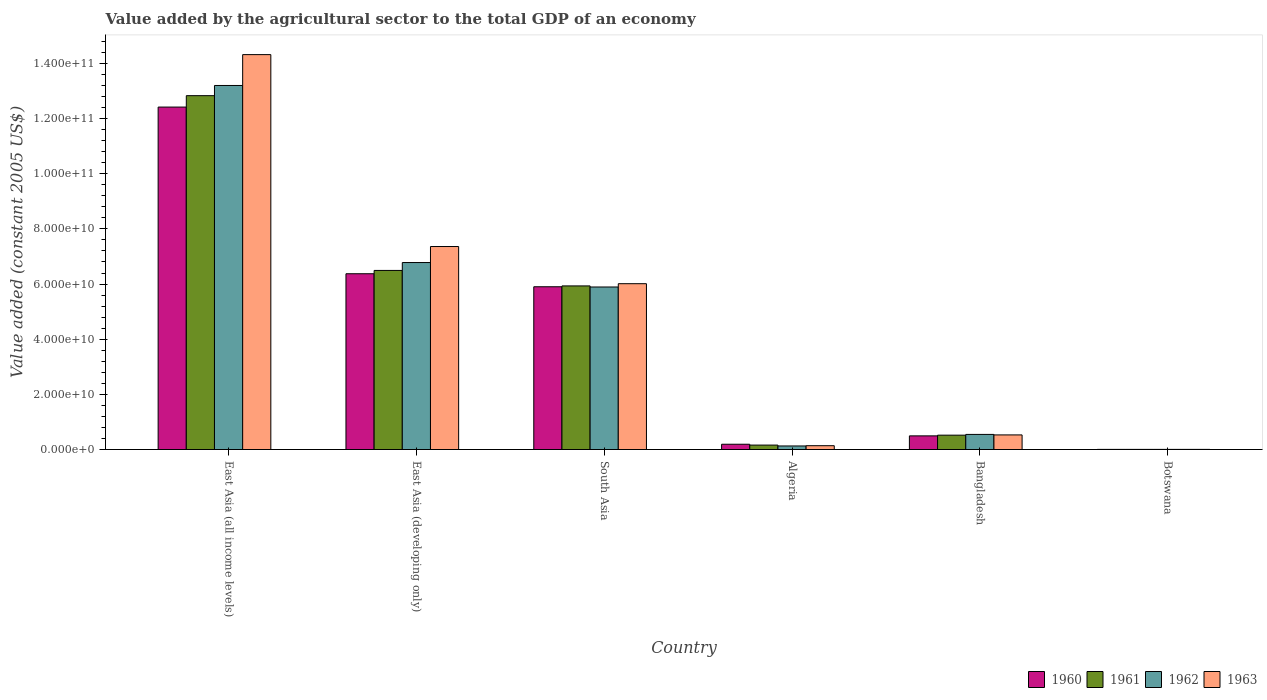Are the number of bars per tick equal to the number of legend labels?
Give a very brief answer. Yes. Are the number of bars on each tick of the X-axis equal?
Keep it short and to the point. Yes. How many bars are there on the 4th tick from the left?
Make the answer very short. 4. How many bars are there on the 3rd tick from the right?
Make the answer very short. 4. What is the label of the 3rd group of bars from the left?
Your answer should be compact. South Asia. What is the value added by the agricultural sector in 1960 in Bangladesh?
Offer a terse response. 4.95e+09. Across all countries, what is the maximum value added by the agricultural sector in 1961?
Provide a succinct answer. 1.28e+11. Across all countries, what is the minimum value added by the agricultural sector in 1960?
Provide a short and direct response. 4.74e+07. In which country was the value added by the agricultural sector in 1963 maximum?
Your answer should be compact. East Asia (all income levels). In which country was the value added by the agricultural sector in 1963 minimum?
Offer a very short reply. Botswana. What is the total value added by the agricultural sector in 1962 in the graph?
Provide a short and direct response. 2.66e+11. What is the difference between the value added by the agricultural sector in 1962 in East Asia (all income levels) and that in South Asia?
Give a very brief answer. 7.31e+1. What is the difference between the value added by the agricultural sector in 1960 in East Asia (all income levels) and the value added by the agricultural sector in 1961 in Algeria?
Your answer should be compact. 1.23e+11. What is the average value added by the agricultural sector in 1962 per country?
Provide a succinct answer. 4.43e+1. What is the difference between the value added by the agricultural sector of/in 1961 and value added by the agricultural sector of/in 1962 in Algeria?
Your answer should be compact. 3.18e+08. What is the ratio of the value added by the agricultural sector in 1963 in Botswana to that in South Asia?
Offer a terse response. 0. Is the difference between the value added by the agricultural sector in 1961 in Algeria and South Asia greater than the difference between the value added by the agricultural sector in 1962 in Algeria and South Asia?
Keep it short and to the point. No. What is the difference between the highest and the second highest value added by the agricultural sector in 1963?
Offer a terse response. -6.96e+1. What is the difference between the highest and the lowest value added by the agricultural sector in 1963?
Ensure brevity in your answer.  1.43e+11. In how many countries, is the value added by the agricultural sector in 1961 greater than the average value added by the agricultural sector in 1961 taken over all countries?
Give a very brief answer. 3. Is it the case that in every country, the sum of the value added by the agricultural sector in 1963 and value added by the agricultural sector in 1961 is greater than the sum of value added by the agricultural sector in 1962 and value added by the agricultural sector in 1960?
Give a very brief answer. No. What does the 4th bar from the right in South Asia represents?
Offer a terse response. 1960. Are all the bars in the graph horizontal?
Your answer should be very brief. No. Are the values on the major ticks of Y-axis written in scientific E-notation?
Ensure brevity in your answer.  Yes. What is the title of the graph?
Give a very brief answer. Value added by the agricultural sector to the total GDP of an economy. Does "1994" appear as one of the legend labels in the graph?
Give a very brief answer. No. What is the label or title of the X-axis?
Your answer should be very brief. Country. What is the label or title of the Y-axis?
Offer a terse response. Value added (constant 2005 US$). What is the Value added (constant 2005 US$) of 1960 in East Asia (all income levels)?
Give a very brief answer. 1.24e+11. What is the Value added (constant 2005 US$) of 1961 in East Asia (all income levels)?
Provide a succinct answer. 1.28e+11. What is the Value added (constant 2005 US$) of 1962 in East Asia (all income levels)?
Make the answer very short. 1.32e+11. What is the Value added (constant 2005 US$) of 1963 in East Asia (all income levels)?
Make the answer very short. 1.43e+11. What is the Value added (constant 2005 US$) in 1960 in East Asia (developing only)?
Give a very brief answer. 6.37e+1. What is the Value added (constant 2005 US$) in 1961 in East Asia (developing only)?
Offer a very short reply. 6.49e+1. What is the Value added (constant 2005 US$) in 1962 in East Asia (developing only)?
Make the answer very short. 6.78e+1. What is the Value added (constant 2005 US$) of 1963 in East Asia (developing only)?
Provide a short and direct response. 7.36e+1. What is the Value added (constant 2005 US$) of 1960 in South Asia?
Your answer should be compact. 5.90e+1. What is the Value added (constant 2005 US$) in 1961 in South Asia?
Provide a succinct answer. 5.93e+1. What is the Value added (constant 2005 US$) in 1962 in South Asia?
Make the answer very short. 5.89e+1. What is the Value added (constant 2005 US$) of 1963 in South Asia?
Make the answer very short. 6.01e+1. What is the Value added (constant 2005 US$) of 1960 in Algeria?
Offer a terse response. 1.92e+09. What is the Value added (constant 2005 US$) in 1961 in Algeria?
Offer a terse response. 1.61e+09. What is the Value added (constant 2005 US$) in 1962 in Algeria?
Offer a very short reply. 1.29e+09. What is the Value added (constant 2005 US$) of 1963 in Algeria?
Ensure brevity in your answer.  1.39e+09. What is the Value added (constant 2005 US$) of 1960 in Bangladesh?
Give a very brief answer. 4.95e+09. What is the Value added (constant 2005 US$) of 1961 in Bangladesh?
Offer a terse response. 5.21e+09. What is the Value added (constant 2005 US$) in 1962 in Bangladesh?
Give a very brief answer. 5.48e+09. What is the Value added (constant 2005 US$) in 1963 in Bangladesh?
Your response must be concise. 5.30e+09. What is the Value added (constant 2005 US$) in 1960 in Botswana?
Provide a short and direct response. 4.74e+07. What is the Value added (constant 2005 US$) in 1961 in Botswana?
Ensure brevity in your answer.  4.86e+07. What is the Value added (constant 2005 US$) of 1962 in Botswana?
Provide a succinct answer. 5.04e+07. What is the Value added (constant 2005 US$) in 1963 in Botswana?
Your answer should be very brief. 5.21e+07. Across all countries, what is the maximum Value added (constant 2005 US$) of 1960?
Your answer should be compact. 1.24e+11. Across all countries, what is the maximum Value added (constant 2005 US$) in 1961?
Your answer should be compact. 1.28e+11. Across all countries, what is the maximum Value added (constant 2005 US$) in 1962?
Offer a terse response. 1.32e+11. Across all countries, what is the maximum Value added (constant 2005 US$) in 1963?
Make the answer very short. 1.43e+11. Across all countries, what is the minimum Value added (constant 2005 US$) in 1960?
Provide a succinct answer. 4.74e+07. Across all countries, what is the minimum Value added (constant 2005 US$) of 1961?
Your answer should be compact. 4.86e+07. Across all countries, what is the minimum Value added (constant 2005 US$) in 1962?
Your answer should be compact. 5.04e+07. Across all countries, what is the minimum Value added (constant 2005 US$) in 1963?
Make the answer very short. 5.21e+07. What is the total Value added (constant 2005 US$) in 1960 in the graph?
Offer a terse response. 2.54e+11. What is the total Value added (constant 2005 US$) in 1961 in the graph?
Your response must be concise. 2.59e+11. What is the total Value added (constant 2005 US$) of 1962 in the graph?
Offer a very short reply. 2.66e+11. What is the total Value added (constant 2005 US$) in 1963 in the graph?
Provide a short and direct response. 2.84e+11. What is the difference between the Value added (constant 2005 US$) in 1960 in East Asia (all income levels) and that in East Asia (developing only)?
Provide a succinct answer. 6.04e+1. What is the difference between the Value added (constant 2005 US$) in 1961 in East Asia (all income levels) and that in East Asia (developing only)?
Keep it short and to the point. 6.34e+1. What is the difference between the Value added (constant 2005 US$) in 1962 in East Asia (all income levels) and that in East Asia (developing only)?
Ensure brevity in your answer.  6.42e+1. What is the difference between the Value added (constant 2005 US$) in 1963 in East Asia (all income levels) and that in East Asia (developing only)?
Provide a succinct answer. 6.96e+1. What is the difference between the Value added (constant 2005 US$) in 1960 in East Asia (all income levels) and that in South Asia?
Ensure brevity in your answer.  6.51e+1. What is the difference between the Value added (constant 2005 US$) in 1961 in East Asia (all income levels) and that in South Asia?
Give a very brief answer. 6.90e+1. What is the difference between the Value added (constant 2005 US$) in 1962 in East Asia (all income levels) and that in South Asia?
Offer a terse response. 7.31e+1. What is the difference between the Value added (constant 2005 US$) of 1963 in East Asia (all income levels) and that in South Asia?
Your response must be concise. 8.31e+1. What is the difference between the Value added (constant 2005 US$) in 1960 in East Asia (all income levels) and that in Algeria?
Keep it short and to the point. 1.22e+11. What is the difference between the Value added (constant 2005 US$) of 1961 in East Asia (all income levels) and that in Algeria?
Ensure brevity in your answer.  1.27e+11. What is the difference between the Value added (constant 2005 US$) of 1962 in East Asia (all income levels) and that in Algeria?
Keep it short and to the point. 1.31e+11. What is the difference between the Value added (constant 2005 US$) in 1963 in East Asia (all income levels) and that in Algeria?
Provide a short and direct response. 1.42e+11. What is the difference between the Value added (constant 2005 US$) in 1960 in East Asia (all income levels) and that in Bangladesh?
Offer a very short reply. 1.19e+11. What is the difference between the Value added (constant 2005 US$) of 1961 in East Asia (all income levels) and that in Bangladesh?
Provide a succinct answer. 1.23e+11. What is the difference between the Value added (constant 2005 US$) of 1962 in East Asia (all income levels) and that in Bangladesh?
Your answer should be compact. 1.27e+11. What is the difference between the Value added (constant 2005 US$) of 1963 in East Asia (all income levels) and that in Bangladesh?
Provide a succinct answer. 1.38e+11. What is the difference between the Value added (constant 2005 US$) of 1960 in East Asia (all income levels) and that in Botswana?
Give a very brief answer. 1.24e+11. What is the difference between the Value added (constant 2005 US$) of 1961 in East Asia (all income levels) and that in Botswana?
Keep it short and to the point. 1.28e+11. What is the difference between the Value added (constant 2005 US$) of 1962 in East Asia (all income levels) and that in Botswana?
Your response must be concise. 1.32e+11. What is the difference between the Value added (constant 2005 US$) of 1963 in East Asia (all income levels) and that in Botswana?
Provide a short and direct response. 1.43e+11. What is the difference between the Value added (constant 2005 US$) in 1960 in East Asia (developing only) and that in South Asia?
Make the answer very short. 4.72e+09. What is the difference between the Value added (constant 2005 US$) in 1961 in East Asia (developing only) and that in South Asia?
Offer a terse response. 5.62e+09. What is the difference between the Value added (constant 2005 US$) in 1962 in East Asia (developing only) and that in South Asia?
Offer a terse response. 8.86e+09. What is the difference between the Value added (constant 2005 US$) in 1963 in East Asia (developing only) and that in South Asia?
Your answer should be very brief. 1.35e+1. What is the difference between the Value added (constant 2005 US$) of 1960 in East Asia (developing only) and that in Algeria?
Offer a terse response. 6.18e+1. What is the difference between the Value added (constant 2005 US$) of 1961 in East Asia (developing only) and that in Algeria?
Offer a terse response. 6.33e+1. What is the difference between the Value added (constant 2005 US$) in 1962 in East Asia (developing only) and that in Algeria?
Offer a terse response. 6.65e+1. What is the difference between the Value added (constant 2005 US$) of 1963 in East Asia (developing only) and that in Algeria?
Your response must be concise. 7.22e+1. What is the difference between the Value added (constant 2005 US$) in 1960 in East Asia (developing only) and that in Bangladesh?
Keep it short and to the point. 5.88e+1. What is the difference between the Value added (constant 2005 US$) in 1961 in East Asia (developing only) and that in Bangladesh?
Provide a succinct answer. 5.97e+1. What is the difference between the Value added (constant 2005 US$) of 1962 in East Asia (developing only) and that in Bangladesh?
Your answer should be very brief. 6.23e+1. What is the difference between the Value added (constant 2005 US$) of 1963 in East Asia (developing only) and that in Bangladesh?
Your response must be concise. 6.83e+1. What is the difference between the Value added (constant 2005 US$) in 1960 in East Asia (developing only) and that in Botswana?
Make the answer very short. 6.37e+1. What is the difference between the Value added (constant 2005 US$) of 1961 in East Asia (developing only) and that in Botswana?
Give a very brief answer. 6.49e+1. What is the difference between the Value added (constant 2005 US$) in 1962 in East Asia (developing only) and that in Botswana?
Your response must be concise. 6.77e+1. What is the difference between the Value added (constant 2005 US$) of 1963 in East Asia (developing only) and that in Botswana?
Offer a terse response. 7.36e+1. What is the difference between the Value added (constant 2005 US$) in 1960 in South Asia and that in Algeria?
Ensure brevity in your answer.  5.71e+1. What is the difference between the Value added (constant 2005 US$) in 1961 in South Asia and that in Algeria?
Offer a very short reply. 5.77e+1. What is the difference between the Value added (constant 2005 US$) of 1962 in South Asia and that in Algeria?
Your answer should be compact. 5.76e+1. What is the difference between the Value added (constant 2005 US$) of 1963 in South Asia and that in Algeria?
Make the answer very short. 5.87e+1. What is the difference between the Value added (constant 2005 US$) of 1960 in South Asia and that in Bangladesh?
Offer a very short reply. 5.41e+1. What is the difference between the Value added (constant 2005 US$) of 1961 in South Asia and that in Bangladesh?
Your response must be concise. 5.41e+1. What is the difference between the Value added (constant 2005 US$) in 1962 in South Asia and that in Bangladesh?
Provide a short and direct response. 5.35e+1. What is the difference between the Value added (constant 2005 US$) of 1963 in South Asia and that in Bangladesh?
Your answer should be very brief. 5.48e+1. What is the difference between the Value added (constant 2005 US$) of 1960 in South Asia and that in Botswana?
Keep it short and to the point. 5.90e+1. What is the difference between the Value added (constant 2005 US$) of 1961 in South Asia and that in Botswana?
Your answer should be compact. 5.93e+1. What is the difference between the Value added (constant 2005 US$) of 1962 in South Asia and that in Botswana?
Your answer should be compact. 5.89e+1. What is the difference between the Value added (constant 2005 US$) of 1963 in South Asia and that in Botswana?
Your answer should be compact. 6.01e+1. What is the difference between the Value added (constant 2005 US$) in 1960 in Algeria and that in Bangladesh?
Your response must be concise. -3.03e+09. What is the difference between the Value added (constant 2005 US$) in 1961 in Algeria and that in Bangladesh?
Offer a terse response. -3.60e+09. What is the difference between the Value added (constant 2005 US$) in 1962 in Algeria and that in Bangladesh?
Offer a very short reply. -4.19e+09. What is the difference between the Value added (constant 2005 US$) of 1963 in Algeria and that in Bangladesh?
Offer a terse response. -3.91e+09. What is the difference between the Value added (constant 2005 US$) in 1960 in Algeria and that in Botswana?
Provide a short and direct response. 1.87e+09. What is the difference between the Value added (constant 2005 US$) of 1961 in Algeria and that in Botswana?
Your response must be concise. 1.56e+09. What is the difference between the Value added (constant 2005 US$) in 1962 in Algeria and that in Botswana?
Offer a terse response. 1.24e+09. What is the difference between the Value added (constant 2005 US$) of 1963 in Algeria and that in Botswana?
Make the answer very short. 1.34e+09. What is the difference between the Value added (constant 2005 US$) of 1960 in Bangladesh and that in Botswana?
Your answer should be compact. 4.90e+09. What is the difference between the Value added (constant 2005 US$) of 1961 in Bangladesh and that in Botswana?
Ensure brevity in your answer.  5.16e+09. What is the difference between the Value added (constant 2005 US$) in 1962 in Bangladesh and that in Botswana?
Keep it short and to the point. 5.43e+09. What is the difference between the Value added (constant 2005 US$) of 1963 in Bangladesh and that in Botswana?
Your answer should be very brief. 5.24e+09. What is the difference between the Value added (constant 2005 US$) of 1960 in East Asia (all income levels) and the Value added (constant 2005 US$) of 1961 in East Asia (developing only)?
Provide a succinct answer. 5.92e+1. What is the difference between the Value added (constant 2005 US$) of 1960 in East Asia (all income levels) and the Value added (constant 2005 US$) of 1962 in East Asia (developing only)?
Your answer should be very brief. 5.64e+1. What is the difference between the Value added (constant 2005 US$) in 1960 in East Asia (all income levels) and the Value added (constant 2005 US$) in 1963 in East Asia (developing only)?
Your response must be concise. 5.06e+1. What is the difference between the Value added (constant 2005 US$) of 1961 in East Asia (all income levels) and the Value added (constant 2005 US$) of 1962 in East Asia (developing only)?
Give a very brief answer. 6.05e+1. What is the difference between the Value added (constant 2005 US$) of 1961 in East Asia (all income levels) and the Value added (constant 2005 US$) of 1963 in East Asia (developing only)?
Offer a very short reply. 5.47e+1. What is the difference between the Value added (constant 2005 US$) in 1962 in East Asia (all income levels) and the Value added (constant 2005 US$) in 1963 in East Asia (developing only)?
Keep it short and to the point. 5.84e+1. What is the difference between the Value added (constant 2005 US$) of 1960 in East Asia (all income levels) and the Value added (constant 2005 US$) of 1961 in South Asia?
Provide a short and direct response. 6.48e+1. What is the difference between the Value added (constant 2005 US$) in 1960 in East Asia (all income levels) and the Value added (constant 2005 US$) in 1962 in South Asia?
Offer a terse response. 6.52e+1. What is the difference between the Value added (constant 2005 US$) of 1960 in East Asia (all income levels) and the Value added (constant 2005 US$) of 1963 in South Asia?
Make the answer very short. 6.40e+1. What is the difference between the Value added (constant 2005 US$) in 1961 in East Asia (all income levels) and the Value added (constant 2005 US$) in 1962 in South Asia?
Give a very brief answer. 6.94e+1. What is the difference between the Value added (constant 2005 US$) in 1961 in East Asia (all income levels) and the Value added (constant 2005 US$) in 1963 in South Asia?
Your answer should be very brief. 6.82e+1. What is the difference between the Value added (constant 2005 US$) in 1962 in East Asia (all income levels) and the Value added (constant 2005 US$) in 1963 in South Asia?
Keep it short and to the point. 7.19e+1. What is the difference between the Value added (constant 2005 US$) of 1960 in East Asia (all income levels) and the Value added (constant 2005 US$) of 1961 in Algeria?
Offer a terse response. 1.23e+11. What is the difference between the Value added (constant 2005 US$) of 1960 in East Asia (all income levels) and the Value added (constant 2005 US$) of 1962 in Algeria?
Keep it short and to the point. 1.23e+11. What is the difference between the Value added (constant 2005 US$) of 1960 in East Asia (all income levels) and the Value added (constant 2005 US$) of 1963 in Algeria?
Your answer should be compact. 1.23e+11. What is the difference between the Value added (constant 2005 US$) in 1961 in East Asia (all income levels) and the Value added (constant 2005 US$) in 1962 in Algeria?
Offer a terse response. 1.27e+11. What is the difference between the Value added (constant 2005 US$) in 1961 in East Asia (all income levels) and the Value added (constant 2005 US$) in 1963 in Algeria?
Your response must be concise. 1.27e+11. What is the difference between the Value added (constant 2005 US$) in 1962 in East Asia (all income levels) and the Value added (constant 2005 US$) in 1963 in Algeria?
Provide a succinct answer. 1.31e+11. What is the difference between the Value added (constant 2005 US$) of 1960 in East Asia (all income levels) and the Value added (constant 2005 US$) of 1961 in Bangladesh?
Your response must be concise. 1.19e+11. What is the difference between the Value added (constant 2005 US$) of 1960 in East Asia (all income levels) and the Value added (constant 2005 US$) of 1962 in Bangladesh?
Your answer should be compact. 1.19e+11. What is the difference between the Value added (constant 2005 US$) in 1960 in East Asia (all income levels) and the Value added (constant 2005 US$) in 1963 in Bangladesh?
Provide a short and direct response. 1.19e+11. What is the difference between the Value added (constant 2005 US$) of 1961 in East Asia (all income levels) and the Value added (constant 2005 US$) of 1962 in Bangladesh?
Give a very brief answer. 1.23e+11. What is the difference between the Value added (constant 2005 US$) in 1961 in East Asia (all income levels) and the Value added (constant 2005 US$) in 1963 in Bangladesh?
Your answer should be compact. 1.23e+11. What is the difference between the Value added (constant 2005 US$) of 1962 in East Asia (all income levels) and the Value added (constant 2005 US$) of 1963 in Bangladesh?
Keep it short and to the point. 1.27e+11. What is the difference between the Value added (constant 2005 US$) of 1960 in East Asia (all income levels) and the Value added (constant 2005 US$) of 1961 in Botswana?
Your answer should be compact. 1.24e+11. What is the difference between the Value added (constant 2005 US$) in 1960 in East Asia (all income levels) and the Value added (constant 2005 US$) in 1962 in Botswana?
Provide a short and direct response. 1.24e+11. What is the difference between the Value added (constant 2005 US$) in 1960 in East Asia (all income levels) and the Value added (constant 2005 US$) in 1963 in Botswana?
Offer a very short reply. 1.24e+11. What is the difference between the Value added (constant 2005 US$) in 1961 in East Asia (all income levels) and the Value added (constant 2005 US$) in 1962 in Botswana?
Provide a succinct answer. 1.28e+11. What is the difference between the Value added (constant 2005 US$) of 1961 in East Asia (all income levels) and the Value added (constant 2005 US$) of 1963 in Botswana?
Give a very brief answer. 1.28e+11. What is the difference between the Value added (constant 2005 US$) of 1962 in East Asia (all income levels) and the Value added (constant 2005 US$) of 1963 in Botswana?
Offer a very short reply. 1.32e+11. What is the difference between the Value added (constant 2005 US$) of 1960 in East Asia (developing only) and the Value added (constant 2005 US$) of 1961 in South Asia?
Provide a succinct answer. 4.42e+09. What is the difference between the Value added (constant 2005 US$) of 1960 in East Asia (developing only) and the Value added (constant 2005 US$) of 1962 in South Asia?
Your answer should be compact. 4.81e+09. What is the difference between the Value added (constant 2005 US$) of 1960 in East Asia (developing only) and the Value added (constant 2005 US$) of 1963 in South Asia?
Keep it short and to the point. 3.61e+09. What is the difference between the Value added (constant 2005 US$) in 1961 in East Asia (developing only) and the Value added (constant 2005 US$) in 1962 in South Asia?
Give a very brief answer. 6.00e+09. What is the difference between the Value added (constant 2005 US$) of 1961 in East Asia (developing only) and the Value added (constant 2005 US$) of 1963 in South Asia?
Keep it short and to the point. 4.81e+09. What is the difference between the Value added (constant 2005 US$) in 1962 in East Asia (developing only) and the Value added (constant 2005 US$) in 1963 in South Asia?
Your answer should be very brief. 7.67e+09. What is the difference between the Value added (constant 2005 US$) in 1960 in East Asia (developing only) and the Value added (constant 2005 US$) in 1961 in Algeria?
Keep it short and to the point. 6.21e+1. What is the difference between the Value added (constant 2005 US$) in 1960 in East Asia (developing only) and the Value added (constant 2005 US$) in 1962 in Algeria?
Offer a terse response. 6.24e+1. What is the difference between the Value added (constant 2005 US$) in 1960 in East Asia (developing only) and the Value added (constant 2005 US$) in 1963 in Algeria?
Your response must be concise. 6.23e+1. What is the difference between the Value added (constant 2005 US$) of 1961 in East Asia (developing only) and the Value added (constant 2005 US$) of 1962 in Algeria?
Your answer should be compact. 6.36e+1. What is the difference between the Value added (constant 2005 US$) in 1961 in East Asia (developing only) and the Value added (constant 2005 US$) in 1963 in Algeria?
Make the answer very short. 6.35e+1. What is the difference between the Value added (constant 2005 US$) of 1962 in East Asia (developing only) and the Value added (constant 2005 US$) of 1963 in Algeria?
Your answer should be very brief. 6.64e+1. What is the difference between the Value added (constant 2005 US$) in 1960 in East Asia (developing only) and the Value added (constant 2005 US$) in 1961 in Bangladesh?
Your answer should be very brief. 5.85e+1. What is the difference between the Value added (constant 2005 US$) in 1960 in East Asia (developing only) and the Value added (constant 2005 US$) in 1962 in Bangladesh?
Offer a very short reply. 5.83e+1. What is the difference between the Value added (constant 2005 US$) of 1960 in East Asia (developing only) and the Value added (constant 2005 US$) of 1963 in Bangladesh?
Provide a short and direct response. 5.84e+1. What is the difference between the Value added (constant 2005 US$) of 1961 in East Asia (developing only) and the Value added (constant 2005 US$) of 1962 in Bangladesh?
Make the answer very short. 5.95e+1. What is the difference between the Value added (constant 2005 US$) in 1961 in East Asia (developing only) and the Value added (constant 2005 US$) in 1963 in Bangladesh?
Make the answer very short. 5.96e+1. What is the difference between the Value added (constant 2005 US$) of 1962 in East Asia (developing only) and the Value added (constant 2005 US$) of 1963 in Bangladesh?
Your answer should be compact. 6.25e+1. What is the difference between the Value added (constant 2005 US$) of 1960 in East Asia (developing only) and the Value added (constant 2005 US$) of 1961 in Botswana?
Offer a terse response. 6.37e+1. What is the difference between the Value added (constant 2005 US$) in 1960 in East Asia (developing only) and the Value added (constant 2005 US$) in 1962 in Botswana?
Provide a succinct answer. 6.37e+1. What is the difference between the Value added (constant 2005 US$) in 1960 in East Asia (developing only) and the Value added (constant 2005 US$) in 1963 in Botswana?
Keep it short and to the point. 6.37e+1. What is the difference between the Value added (constant 2005 US$) in 1961 in East Asia (developing only) and the Value added (constant 2005 US$) in 1962 in Botswana?
Offer a terse response. 6.49e+1. What is the difference between the Value added (constant 2005 US$) in 1961 in East Asia (developing only) and the Value added (constant 2005 US$) in 1963 in Botswana?
Give a very brief answer. 6.49e+1. What is the difference between the Value added (constant 2005 US$) in 1962 in East Asia (developing only) and the Value added (constant 2005 US$) in 1963 in Botswana?
Make the answer very short. 6.77e+1. What is the difference between the Value added (constant 2005 US$) in 1960 in South Asia and the Value added (constant 2005 US$) in 1961 in Algeria?
Keep it short and to the point. 5.74e+1. What is the difference between the Value added (constant 2005 US$) in 1960 in South Asia and the Value added (constant 2005 US$) in 1962 in Algeria?
Provide a succinct answer. 5.77e+1. What is the difference between the Value added (constant 2005 US$) in 1960 in South Asia and the Value added (constant 2005 US$) in 1963 in Algeria?
Your answer should be compact. 5.76e+1. What is the difference between the Value added (constant 2005 US$) of 1961 in South Asia and the Value added (constant 2005 US$) of 1962 in Algeria?
Provide a succinct answer. 5.80e+1. What is the difference between the Value added (constant 2005 US$) of 1961 in South Asia and the Value added (constant 2005 US$) of 1963 in Algeria?
Offer a very short reply. 5.79e+1. What is the difference between the Value added (constant 2005 US$) in 1962 in South Asia and the Value added (constant 2005 US$) in 1963 in Algeria?
Your answer should be compact. 5.75e+1. What is the difference between the Value added (constant 2005 US$) of 1960 in South Asia and the Value added (constant 2005 US$) of 1961 in Bangladesh?
Your answer should be compact. 5.38e+1. What is the difference between the Value added (constant 2005 US$) in 1960 in South Asia and the Value added (constant 2005 US$) in 1962 in Bangladesh?
Give a very brief answer. 5.35e+1. What is the difference between the Value added (constant 2005 US$) of 1960 in South Asia and the Value added (constant 2005 US$) of 1963 in Bangladesh?
Your response must be concise. 5.37e+1. What is the difference between the Value added (constant 2005 US$) in 1961 in South Asia and the Value added (constant 2005 US$) in 1962 in Bangladesh?
Give a very brief answer. 5.38e+1. What is the difference between the Value added (constant 2005 US$) of 1961 in South Asia and the Value added (constant 2005 US$) of 1963 in Bangladesh?
Offer a terse response. 5.40e+1. What is the difference between the Value added (constant 2005 US$) of 1962 in South Asia and the Value added (constant 2005 US$) of 1963 in Bangladesh?
Make the answer very short. 5.36e+1. What is the difference between the Value added (constant 2005 US$) in 1960 in South Asia and the Value added (constant 2005 US$) in 1961 in Botswana?
Ensure brevity in your answer.  5.90e+1. What is the difference between the Value added (constant 2005 US$) in 1960 in South Asia and the Value added (constant 2005 US$) in 1962 in Botswana?
Your response must be concise. 5.90e+1. What is the difference between the Value added (constant 2005 US$) in 1960 in South Asia and the Value added (constant 2005 US$) in 1963 in Botswana?
Your answer should be compact. 5.90e+1. What is the difference between the Value added (constant 2005 US$) in 1961 in South Asia and the Value added (constant 2005 US$) in 1962 in Botswana?
Make the answer very short. 5.93e+1. What is the difference between the Value added (constant 2005 US$) of 1961 in South Asia and the Value added (constant 2005 US$) of 1963 in Botswana?
Make the answer very short. 5.93e+1. What is the difference between the Value added (constant 2005 US$) in 1962 in South Asia and the Value added (constant 2005 US$) in 1963 in Botswana?
Offer a very short reply. 5.89e+1. What is the difference between the Value added (constant 2005 US$) in 1960 in Algeria and the Value added (constant 2005 US$) in 1961 in Bangladesh?
Give a very brief answer. -3.29e+09. What is the difference between the Value added (constant 2005 US$) in 1960 in Algeria and the Value added (constant 2005 US$) in 1962 in Bangladesh?
Offer a terse response. -3.56e+09. What is the difference between the Value added (constant 2005 US$) of 1960 in Algeria and the Value added (constant 2005 US$) of 1963 in Bangladesh?
Your response must be concise. -3.38e+09. What is the difference between the Value added (constant 2005 US$) in 1961 in Algeria and the Value added (constant 2005 US$) in 1962 in Bangladesh?
Your answer should be very brief. -3.87e+09. What is the difference between the Value added (constant 2005 US$) of 1961 in Algeria and the Value added (constant 2005 US$) of 1963 in Bangladesh?
Your answer should be very brief. -3.69e+09. What is the difference between the Value added (constant 2005 US$) of 1962 in Algeria and the Value added (constant 2005 US$) of 1963 in Bangladesh?
Keep it short and to the point. -4.00e+09. What is the difference between the Value added (constant 2005 US$) in 1960 in Algeria and the Value added (constant 2005 US$) in 1961 in Botswana?
Give a very brief answer. 1.87e+09. What is the difference between the Value added (constant 2005 US$) of 1960 in Algeria and the Value added (constant 2005 US$) of 1962 in Botswana?
Offer a terse response. 1.86e+09. What is the difference between the Value added (constant 2005 US$) of 1960 in Algeria and the Value added (constant 2005 US$) of 1963 in Botswana?
Your answer should be compact. 1.86e+09. What is the difference between the Value added (constant 2005 US$) of 1961 in Algeria and the Value added (constant 2005 US$) of 1962 in Botswana?
Offer a very short reply. 1.56e+09. What is the difference between the Value added (constant 2005 US$) in 1961 in Algeria and the Value added (constant 2005 US$) in 1963 in Botswana?
Offer a terse response. 1.56e+09. What is the difference between the Value added (constant 2005 US$) in 1962 in Algeria and the Value added (constant 2005 US$) in 1963 in Botswana?
Ensure brevity in your answer.  1.24e+09. What is the difference between the Value added (constant 2005 US$) of 1960 in Bangladesh and the Value added (constant 2005 US$) of 1961 in Botswana?
Offer a very short reply. 4.90e+09. What is the difference between the Value added (constant 2005 US$) in 1960 in Bangladesh and the Value added (constant 2005 US$) in 1962 in Botswana?
Keep it short and to the point. 4.90e+09. What is the difference between the Value added (constant 2005 US$) of 1960 in Bangladesh and the Value added (constant 2005 US$) of 1963 in Botswana?
Make the answer very short. 4.90e+09. What is the difference between the Value added (constant 2005 US$) in 1961 in Bangladesh and the Value added (constant 2005 US$) in 1962 in Botswana?
Give a very brief answer. 5.16e+09. What is the difference between the Value added (constant 2005 US$) in 1961 in Bangladesh and the Value added (constant 2005 US$) in 1963 in Botswana?
Your answer should be compact. 5.15e+09. What is the difference between the Value added (constant 2005 US$) of 1962 in Bangladesh and the Value added (constant 2005 US$) of 1963 in Botswana?
Give a very brief answer. 5.43e+09. What is the average Value added (constant 2005 US$) of 1960 per country?
Keep it short and to the point. 4.23e+1. What is the average Value added (constant 2005 US$) of 1961 per country?
Keep it short and to the point. 4.32e+1. What is the average Value added (constant 2005 US$) in 1962 per country?
Give a very brief answer. 4.43e+1. What is the average Value added (constant 2005 US$) in 1963 per country?
Offer a very short reply. 4.73e+1. What is the difference between the Value added (constant 2005 US$) in 1960 and Value added (constant 2005 US$) in 1961 in East Asia (all income levels)?
Your answer should be compact. -4.14e+09. What is the difference between the Value added (constant 2005 US$) of 1960 and Value added (constant 2005 US$) of 1962 in East Asia (all income levels)?
Your answer should be very brief. -7.83e+09. What is the difference between the Value added (constant 2005 US$) of 1960 and Value added (constant 2005 US$) of 1963 in East Asia (all income levels)?
Offer a terse response. -1.90e+1. What is the difference between the Value added (constant 2005 US$) in 1961 and Value added (constant 2005 US$) in 1962 in East Asia (all income levels)?
Your response must be concise. -3.69e+09. What is the difference between the Value added (constant 2005 US$) in 1961 and Value added (constant 2005 US$) in 1963 in East Asia (all income levels)?
Your answer should be compact. -1.49e+1. What is the difference between the Value added (constant 2005 US$) in 1962 and Value added (constant 2005 US$) in 1963 in East Asia (all income levels)?
Make the answer very short. -1.12e+1. What is the difference between the Value added (constant 2005 US$) in 1960 and Value added (constant 2005 US$) in 1961 in East Asia (developing only)?
Your answer should be compact. -1.20e+09. What is the difference between the Value added (constant 2005 US$) of 1960 and Value added (constant 2005 US$) of 1962 in East Asia (developing only)?
Provide a succinct answer. -4.06e+09. What is the difference between the Value added (constant 2005 US$) of 1960 and Value added (constant 2005 US$) of 1963 in East Asia (developing only)?
Offer a very short reply. -9.86e+09. What is the difference between the Value added (constant 2005 US$) of 1961 and Value added (constant 2005 US$) of 1962 in East Asia (developing only)?
Provide a short and direct response. -2.86e+09. What is the difference between the Value added (constant 2005 US$) of 1961 and Value added (constant 2005 US$) of 1963 in East Asia (developing only)?
Your response must be concise. -8.67e+09. What is the difference between the Value added (constant 2005 US$) of 1962 and Value added (constant 2005 US$) of 1963 in East Asia (developing only)?
Your answer should be compact. -5.81e+09. What is the difference between the Value added (constant 2005 US$) in 1960 and Value added (constant 2005 US$) in 1961 in South Asia?
Your answer should be compact. -3.02e+08. What is the difference between the Value added (constant 2005 US$) in 1960 and Value added (constant 2005 US$) in 1962 in South Asia?
Offer a very short reply. 8.71e+07. What is the difference between the Value added (constant 2005 US$) in 1960 and Value added (constant 2005 US$) in 1963 in South Asia?
Provide a succinct answer. -1.11e+09. What is the difference between the Value added (constant 2005 US$) in 1961 and Value added (constant 2005 US$) in 1962 in South Asia?
Offer a very short reply. 3.89e+08. What is the difference between the Value added (constant 2005 US$) of 1961 and Value added (constant 2005 US$) of 1963 in South Asia?
Your answer should be very brief. -8.04e+08. What is the difference between the Value added (constant 2005 US$) of 1962 and Value added (constant 2005 US$) of 1963 in South Asia?
Provide a short and direct response. -1.19e+09. What is the difference between the Value added (constant 2005 US$) of 1960 and Value added (constant 2005 US$) of 1961 in Algeria?
Keep it short and to the point. 3.07e+08. What is the difference between the Value added (constant 2005 US$) of 1960 and Value added (constant 2005 US$) of 1962 in Algeria?
Your response must be concise. 6.25e+08. What is the difference between the Value added (constant 2005 US$) of 1960 and Value added (constant 2005 US$) of 1963 in Algeria?
Give a very brief answer. 5.27e+08. What is the difference between the Value added (constant 2005 US$) in 1961 and Value added (constant 2005 US$) in 1962 in Algeria?
Offer a very short reply. 3.18e+08. What is the difference between the Value added (constant 2005 US$) in 1961 and Value added (constant 2005 US$) in 1963 in Algeria?
Your response must be concise. 2.20e+08. What is the difference between the Value added (constant 2005 US$) of 1962 and Value added (constant 2005 US$) of 1963 in Algeria?
Offer a very short reply. -9.79e+07. What is the difference between the Value added (constant 2005 US$) of 1960 and Value added (constant 2005 US$) of 1961 in Bangladesh?
Ensure brevity in your answer.  -2.58e+08. What is the difference between the Value added (constant 2005 US$) in 1960 and Value added (constant 2005 US$) in 1962 in Bangladesh?
Offer a terse response. -5.31e+08. What is the difference between the Value added (constant 2005 US$) in 1960 and Value added (constant 2005 US$) in 1963 in Bangladesh?
Give a very brief answer. -3.47e+08. What is the difference between the Value added (constant 2005 US$) of 1961 and Value added (constant 2005 US$) of 1962 in Bangladesh?
Your answer should be compact. -2.73e+08. What is the difference between the Value added (constant 2005 US$) of 1961 and Value added (constant 2005 US$) of 1963 in Bangladesh?
Provide a succinct answer. -8.88e+07. What is the difference between the Value added (constant 2005 US$) of 1962 and Value added (constant 2005 US$) of 1963 in Bangladesh?
Keep it short and to the point. 1.84e+08. What is the difference between the Value added (constant 2005 US$) in 1960 and Value added (constant 2005 US$) in 1961 in Botswana?
Keep it short and to the point. -1.17e+06. What is the difference between the Value added (constant 2005 US$) of 1960 and Value added (constant 2005 US$) of 1962 in Botswana?
Give a very brief answer. -2.92e+06. What is the difference between the Value added (constant 2005 US$) in 1960 and Value added (constant 2005 US$) in 1963 in Botswana?
Give a very brief answer. -4.67e+06. What is the difference between the Value added (constant 2005 US$) of 1961 and Value added (constant 2005 US$) of 1962 in Botswana?
Keep it short and to the point. -1.75e+06. What is the difference between the Value added (constant 2005 US$) in 1961 and Value added (constant 2005 US$) in 1963 in Botswana?
Your answer should be very brief. -3.51e+06. What is the difference between the Value added (constant 2005 US$) in 1962 and Value added (constant 2005 US$) in 1963 in Botswana?
Offer a terse response. -1.75e+06. What is the ratio of the Value added (constant 2005 US$) of 1960 in East Asia (all income levels) to that in East Asia (developing only)?
Offer a terse response. 1.95. What is the ratio of the Value added (constant 2005 US$) in 1961 in East Asia (all income levels) to that in East Asia (developing only)?
Give a very brief answer. 1.98. What is the ratio of the Value added (constant 2005 US$) of 1962 in East Asia (all income levels) to that in East Asia (developing only)?
Provide a short and direct response. 1.95. What is the ratio of the Value added (constant 2005 US$) in 1963 in East Asia (all income levels) to that in East Asia (developing only)?
Keep it short and to the point. 1.95. What is the ratio of the Value added (constant 2005 US$) in 1960 in East Asia (all income levels) to that in South Asia?
Make the answer very short. 2.1. What is the ratio of the Value added (constant 2005 US$) in 1961 in East Asia (all income levels) to that in South Asia?
Keep it short and to the point. 2.16. What is the ratio of the Value added (constant 2005 US$) of 1962 in East Asia (all income levels) to that in South Asia?
Make the answer very short. 2.24. What is the ratio of the Value added (constant 2005 US$) of 1963 in East Asia (all income levels) to that in South Asia?
Provide a succinct answer. 2.38. What is the ratio of the Value added (constant 2005 US$) of 1960 in East Asia (all income levels) to that in Algeria?
Keep it short and to the point. 64.83. What is the ratio of the Value added (constant 2005 US$) in 1961 in East Asia (all income levels) to that in Algeria?
Offer a very short reply. 79.77. What is the ratio of the Value added (constant 2005 US$) of 1962 in East Asia (all income levels) to that in Algeria?
Provide a succinct answer. 102.31. What is the ratio of the Value added (constant 2005 US$) in 1963 in East Asia (all income levels) to that in Algeria?
Make the answer very short. 103.15. What is the ratio of the Value added (constant 2005 US$) in 1960 in East Asia (all income levels) to that in Bangladesh?
Offer a very short reply. 25.09. What is the ratio of the Value added (constant 2005 US$) in 1961 in East Asia (all income levels) to that in Bangladesh?
Give a very brief answer. 24.64. What is the ratio of the Value added (constant 2005 US$) in 1962 in East Asia (all income levels) to that in Bangladesh?
Your response must be concise. 24.09. What is the ratio of the Value added (constant 2005 US$) in 1963 in East Asia (all income levels) to that in Bangladesh?
Your response must be concise. 27.04. What is the ratio of the Value added (constant 2005 US$) of 1960 in East Asia (all income levels) to that in Botswana?
Make the answer very short. 2616.96. What is the ratio of the Value added (constant 2005 US$) in 1961 in East Asia (all income levels) to that in Botswana?
Offer a very short reply. 2639.15. What is the ratio of the Value added (constant 2005 US$) in 1962 in East Asia (all income levels) to that in Botswana?
Ensure brevity in your answer.  2620.64. What is the ratio of the Value added (constant 2005 US$) of 1963 in East Asia (all income levels) to that in Botswana?
Your answer should be very brief. 2747.19. What is the ratio of the Value added (constant 2005 US$) in 1961 in East Asia (developing only) to that in South Asia?
Give a very brief answer. 1.09. What is the ratio of the Value added (constant 2005 US$) of 1962 in East Asia (developing only) to that in South Asia?
Provide a succinct answer. 1.15. What is the ratio of the Value added (constant 2005 US$) of 1963 in East Asia (developing only) to that in South Asia?
Give a very brief answer. 1.22. What is the ratio of the Value added (constant 2005 US$) in 1960 in East Asia (developing only) to that in Algeria?
Keep it short and to the point. 33.28. What is the ratio of the Value added (constant 2005 US$) in 1961 in East Asia (developing only) to that in Algeria?
Offer a very short reply. 40.37. What is the ratio of the Value added (constant 2005 US$) of 1962 in East Asia (developing only) to that in Algeria?
Provide a succinct answer. 52.55. What is the ratio of the Value added (constant 2005 US$) of 1963 in East Asia (developing only) to that in Algeria?
Offer a very short reply. 53.02. What is the ratio of the Value added (constant 2005 US$) in 1960 in East Asia (developing only) to that in Bangladesh?
Keep it short and to the point. 12.88. What is the ratio of the Value added (constant 2005 US$) of 1961 in East Asia (developing only) to that in Bangladesh?
Provide a short and direct response. 12.47. What is the ratio of the Value added (constant 2005 US$) of 1962 in East Asia (developing only) to that in Bangladesh?
Give a very brief answer. 12.37. What is the ratio of the Value added (constant 2005 US$) in 1963 in East Asia (developing only) to that in Bangladesh?
Offer a very short reply. 13.9. What is the ratio of the Value added (constant 2005 US$) of 1960 in East Asia (developing only) to that in Botswana?
Offer a terse response. 1343.36. What is the ratio of the Value added (constant 2005 US$) in 1961 in East Asia (developing only) to that in Botswana?
Offer a terse response. 1335.7. What is the ratio of the Value added (constant 2005 US$) of 1962 in East Asia (developing only) to that in Botswana?
Your answer should be compact. 1345.99. What is the ratio of the Value added (constant 2005 US$) of 1963 in East Asia (developing only) to that in Botswana?
Your response must be concise. 1412.14. What is the ratio of the Value added (constant 2005 US$) of 1960 in South Asia to that in Algeria?
Give a very brief answer. 30.81. What is the ratio of the Value added (constant 2005 US$) of 1961 in South Asia to that in Algeria?
Offer a terse response. 36.88. What is the ratio of the Value added (constant 2005 US$) of 1962 in South Asia to that in Algeria?
Provide a short and direct response. 45.68. What is the ratio of the Value added (constant 2005 US$) in 1963 in South Asia to that in Algeria?
Your response must be concise. 43.31. What is the ratio of the Value added (constant 2005 US$) of 1960 in South Asia to that in Bangladesh?
Keep it short and to the point. 11.93. What is the ratio of the Value added (constant 2005 US$) in 1961 in South Asia to that in Bangladesh?
Ensure brevity in your answer.  11.39. What is the ratio of the Value added (constant 2005 US$) of 1962 in South Asia to that in Bangladesh?
Give a very brief answer. 10.75. What is the ratio of the Value added (constant 2005 US$) of 1963 in South Asia to that in Bangladesh?
Keep it short and to the point. 11.35. What is the ratio of the Value added (constant 2005 US$) of 1960 in South Asia to that in Botswana?
Your response must be concise. 1243.88. What is the ratio of the Value added (constant 2005 US$) of 1961 in South Asia to that in Botswana?
Make the answer very short. 1220.19. What is the ratio of the Value added (constant 2005 US$) in 1962 in South Asia to that in Botswana?
Provide a short and direct response. 1170. What is the ratio of the Value added (constant 2005 US$) in 1963 in South Asia to that in Botswana?
Keep it short and to the point. 1153.54. What is the ratio of the Value added (constant 2005 US$) of 1960 in Algeria to that in Bangladesh?
Keep it short and to the point. 0.39. What is the ratio of the Value added (constant 2005 US$) in 1961 in Algeria to that in Bangladesh?
Make the answer very short. 0.31. What is the ratio of the Value added (constant 2005 US$) of 1962 in Algeria to that in Bangladesh?
Your answer should be very brief. 0.24. What is the ratio of the Value added (constant 2005 US$) in 1963 in Algeria to that in Bangladesh?
Provide a short and direct response. 0.26. What is the ratio of the Value added (constant 2005 US$) of 1960 in Algeria to that in Botswana?
Give a very brief answer. 40.37. What is the ratio of the Value added (constant 2005 US$) in 1961 in Algeria to that in Botswana?
Your answer should be compact. 33.08. What is the ratio of the Value added (constant 2005 US$) of 1962 in Algeria to that in Botswana?
Your response must be concise. 25.62. What is the ratio of the Value added (constant 2005 US$) of 1963 in Algeria to that in Botswana?
Offer a terse response. 26.63. What is the ratio of the Value added (constant 2005 US$) of 1960 in Bangladesh to that in Botswana?
Provide a short and direct response. 104.3. What is the ratio of the Value added (constant 2005 US$) in 1961 in Bangladesh to that in Botswana?
Offer a very short reply. 107.09. What is the ratio of the Value added (constant 2005 US$) of 1962 in Bangladesh to that in Botswana?
Provide a short and direct response. 108.79. What is the ratio of the Value added (constant 2005 US$) of 1963 in Bangladesh to that in Botswana?
Give a very brief answer. 101.59. What is the difference between the highest and the second highest Value added (constant 2005 US$) of 1960?
Offer a very short reply. 6.04e+1. What is the difference between the highest and the second highest Value added (constant 2005 US$) of 1961?
Offer a very short reply. 6.34e+1. What is the difference between the highest and the second highest Value added (constant 2005 US$) in 1962?
Ensure brevity in your answer.  6.42e+1. What is the difference between the highest and the second highest Value added (constant 2005 US$) in 1963?
Offer a terse response. 6.96e+1. What is the difference between the highest and the lowest Value added (constant 2005 US$) of 1960?
Your response must be concise. 1.24e+11. What is the difference between the highest and the lowest Value added (constant 2005 US$) in 1961?
Your answer should be compact. 1.28e+11. What is the difference between the highest and the lowest Value added (constant 2005 US$) in 1962?
Keep it short and to the point. 1.32e+11. What is the difference between the highest and the lowest Value added (constant 2005 US$) of 1963?
Offer a very short reply. 1.43e+11. 